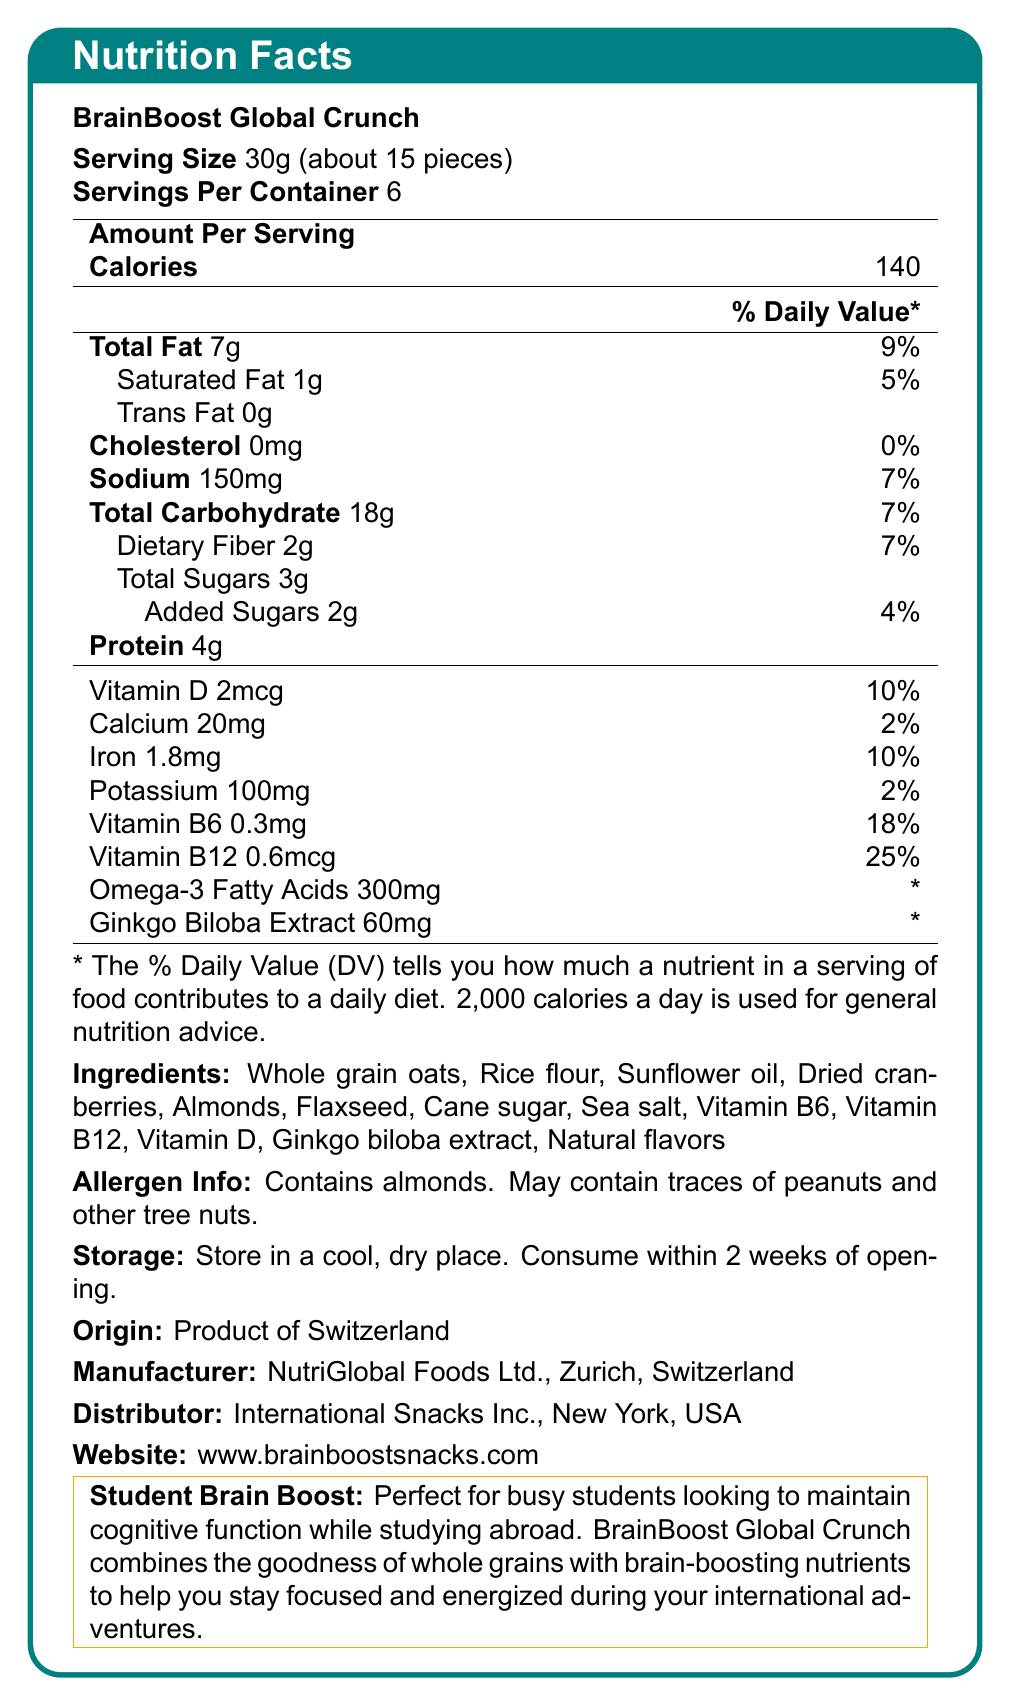what is the product name? The product name is explicitly mentioned at the beginning of the document.
Answer: BrainBoost Global Crunch how many servings are in each container? The document states that there are 6 servings per container.
Answer: 6 what is the serving size? The specified serving size is mentioned as 30g, which is approximately 15 pieces.
Answer: 30g (about 15 pieces) how many calories are in one serving? The document states that there are 140 calories per serving.
Answer: 140 what is the amount of vitamin B12 per serving? The Nutrition Facts section lists vitamin B12 content as 0.6mcg per serving.
Answer: 0.6mcg How much total fat does one serving contain and how does it contribute to the daily value? One serving contains 7g of total fat, contributing 9% to the daily value.
Answer: 7g, 9% what are the main ingredients of BrainBoost Global Crunch? The ingredients are listed in the designated section of the document.
Answer: Whole grain oats, Rice flour, Sunflower oil, Dried cranberries, Almonds, Flaxseed, Cane sugar, Sea salt, Vitamin B6, Vitamin B12, Vitamin D, Ginkgo biloba extract, Natural flavors what allergens does BrainBoost Global Crunch contain? The allergen information section states it contains almonds and may contain traces of peanuts and other tree nuts.
Answer: Contains almonds. May contain traces of peanuts and other tree nuts. where is BrainBoost Global Crunch manufactured? The document mentions that the product is manufactured by NutriGlobal Foods Ltd. in Zurich, Switzerland.
Answer: NutriGlobal Foods Ltd., Zurich, Switzerland what storage instructions are given for BrainBoost Global Crunch? The storage instructions specify storing the product in a cool, dry place and consuming it within 2 weeks of opening.
Answer: Store in a cool, dry place. Consume within 2 weeks of opening. What is the main function of BrainBoost Global Crunch according to the document? A. Help with weight loss B. Enhance cognitive function C. Provide a high protein snack D. Boost immune system The document mentions the snack is perfect for busy students looking to maintain cognitive function.
Answer: B. Enhance cognitive function What is the daily value percentage of dietary fiber per serving? A. 5% B. 7% C. 10% D. 15% The document states that each serving contains 2g of dietary fiber, which is 7% of the daily value.
Answer: B. 7% What percentage of daily value does Vitamin D contribute per serving? A. 2% B. 10% C. 25% D. 18% The document indicates that each serving provides 2mcg of Vitamin D, contributing to 10% of the daily value.
Answer: B. 10% Is BrainBoost Global Crunch suitable for someone with a peanut allergy? (Yes/No) The document states that the product contains almonds and may contain traces of peanuts and other tree nuts, making it unsuitable for someone with a peanut allergy.
Answer: No Summarize the main details provided in the document. The document details the nutritional content, ingredients, allergens, storage instructions, and manufacturer information for BrainBoost Global Crunch, emphasizing its cognitive benefits for students.
Answer: BrainBoost Global Crunch is an international snack designed to maintain cognitive function, consisting of whole grains and various brain-boosting nutrients. Each 30g serving contains 140 calories, 7g of fat, 18g of carbohydrates, and 4g of protein. It includes essential vitamins and minerals like Vitamin B6, B12, and D, as well as omega-3 fatty acids and ginkgo biloba extract. The product contains almonds and may have traces of other nuts, is made in Switzerland, and needs to be stored in a cool, dry place. How much Omega-3 fatty acids does each serving of BrainBoost Global Crunch contain? The Nutrition Facts section indicates each serving contains 300mg of Omega-3 fatty acids.
Answer: 300mg What is the total amount of sugars in one serving? The document lists the total sugars as 3g per serving.
Answer: 3g what is the price of BrainBoost Global Crunch? The document does not provide any information regarding the price of BrainBoost Global Crunch.
Answer: Not enough information 